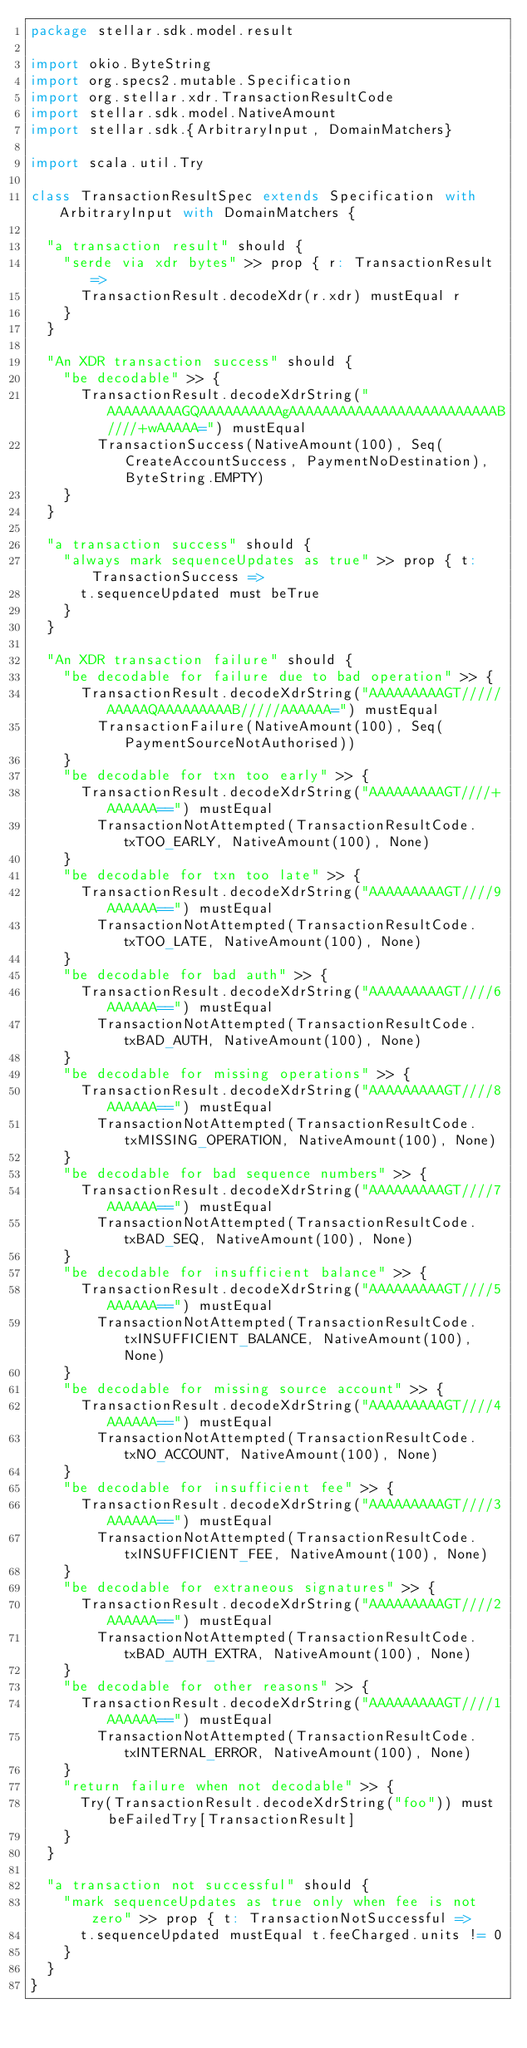Convert code to text. <code><loc_0><loc_0><loc_500><loc_500><_Scala_>package stellar.sdk.model.result

import okio.ByteString
import org.specs2.mutable.Specification
import org.stellar.xdr.TransactionResultCode
import stellar.sdk.model.NativeAmount
import stellar.sdk.{ArbitraryInput, DomainMatchers}

import scala.util.Try

class TransactionResultSpec extends Specification with ArbitraryInput with DomainMatchers {

  "a transaction result" should {
    "serde via xdr bytes" >> prop { r: TransactionResult =>
      TransactionResult.decodeXdr(r.xdr) mustEqual r
    }
  }

  "An XDR transaction success" should {
    "be decodable" >> {
      TransactionResult.decodeXdrString("AAAAAAAAAGQAAAAAAAAAAgAAAAAAAAAAAAAAAAAAAAAAAAAB////+wAAAAA=") mustEqual
        TransactionSuccess(NativeAmount(100), Seq(CreateAccountSuccess, PaymentNoDestination), ByteString.EMPTY)
    }
  }

  "a transaction success" should {
    "always mark sequenceUpdates as true" >> prop { t: TransactionSuccess =>
      t.sequenceUpdated must beTrue
    }
  }

  "An XDR transaction failure" should {
    "be decodable for failure due to bad operation" >> {
      TransactionResult.decodeXdrString("AAAAAAAAAGT/////AAAAAQAAAAAAAAAB/////AAAAAA=") mustEqual
        TransactionFailure(NativeAmount(100), Seq(PaymentSourceNotAuthorised))
    }
    "be decodable for txn too early" >> {
      TransactionResult.decodeXdrString("AAAAAAAAAGT////+AAAAAA==") mustEqual
        TransactionNotAttempted(TransactionResultCode.txTOO_EARLY, NativeAmount(100), None)
    }
    "be decodable for txn too late" >> {
      TransactionResult.decodeXdrString("AAAAAAAAAGT////9AAAAAA==") mustEqual
        TransactionNotAttempted(TransactionResultCode.txTOO_LATE, NativeAmount(100), None)
    }
    "be decodable for bad auth" >> {
      TransactionResult.decodeXdrString("AAAAAAAAAGT////6AAAAAA==") mustEqual
        TransactionNotAttempted(TransactionResultCode.txBAD_AUTH, NativeAmount(100), None)
    }
    "be decodable for missing operations" >> {
      TransactionResult.decodeXdrString("AAAAAAAAAGT////8AAAAAA==") mustEqual
        TransactionNotAttempted(TransactionResultCode.txMISSING_OPERATION, NativeAmount(100), None)
    }
    "be decodable for bad sequence numbers" >> {
      TransactionResult.decodeXdrString("AAAAAAAAAGT////7AAAAAA==") mustEqual
        TransactionNotAttempted(TransactionResultCode.txBAD_SEQ, NativeAmount(100), None)
    }
    "be decodable for insufficient balance" >> {
      TransactionResult.decodeXdrString("AAAAAAAAAGT////5AAAAAA==") mustEqual
        TransactionNotAttempted(TransactionResultCode.txINSUFFICIENT_BALANCE, NativeAmount(100), None)
    }
    "be decodable for missing source account" >> {
      TransactionResult.decodeXdrString("AAAAAAAAAGT////4AAAAAA==") mustEqual
        TransactionNotAttempted(TransactionResultCode.txNO_ACCOUNT, NativeAmount(100), None)
    }
    "be decodable for insufficient fee" >> {
      TransactionResult.decodeXdrString("AAAAAAAAAGT////3AAAAAA==") mustEqual
        TransactionNotAttempted(TransactionResultCode.txINSUFFICIENT_FEE, NativeAmount(100), None)
    }
    "be decodable for extraneous signatures" >> {
      TransactionResult.decodeXdrString("AAAAAAAAAGT////2AAAAAA==") mustEqual
        TransactionNotAttempted(TransactionResultCode.txBAD_AUTH_EXTRA, NativeAmount(100), None)
    }
    "be decodable for other reasons" >> {
      TransactionResult.decodeXdrString("AAAAAAAAAGT////1AAAAAA==") mustEqual
        TransactionNotAttempted(TransactionResultCode.txINTERNAL_ERROR, NativeAmount(100), None)
    }
    "return failure when not decodable" >> {
      Try(TransactionResult.decodeXdrString("foo")) must beFailedTry[TransactionResult]
    }
  }

  "a transaction not successful" should {
    "mark sequenceUpdates as true only when fee is not zero" >> prop { t: TransactionNotSuccessful =>
      t.sequenceUpdated mustEqual t.feeCharged.units != 0
    }
  }
}
</code> 